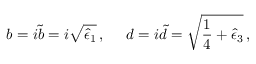<formula> <loc_0><loc_0><loc_500><loc_500>b = i \tilde { b } = i \sqrt { \hat { \epsilon } _ { 1 } } \, , \, d = i \tilde { d } = \sqrt { \frac { 1 } { 4 } + \hat { \epsilon } _ { 3 } } \, ,</formula> 